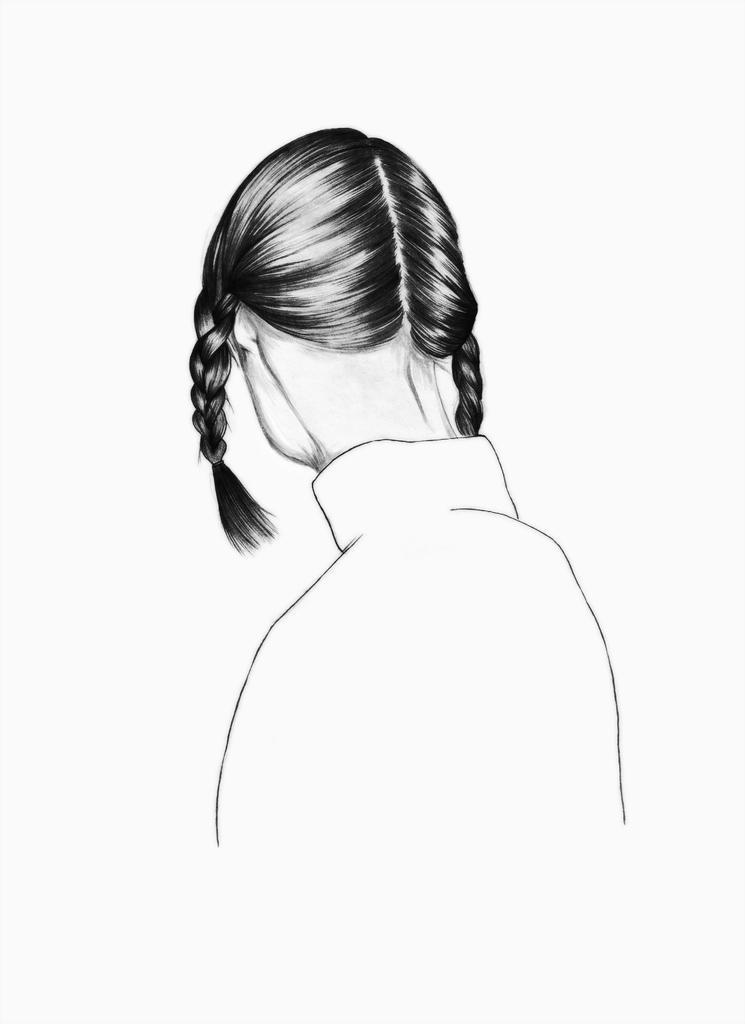Describe this image in one or two sentences. In this image there is a drawing of a lady. 